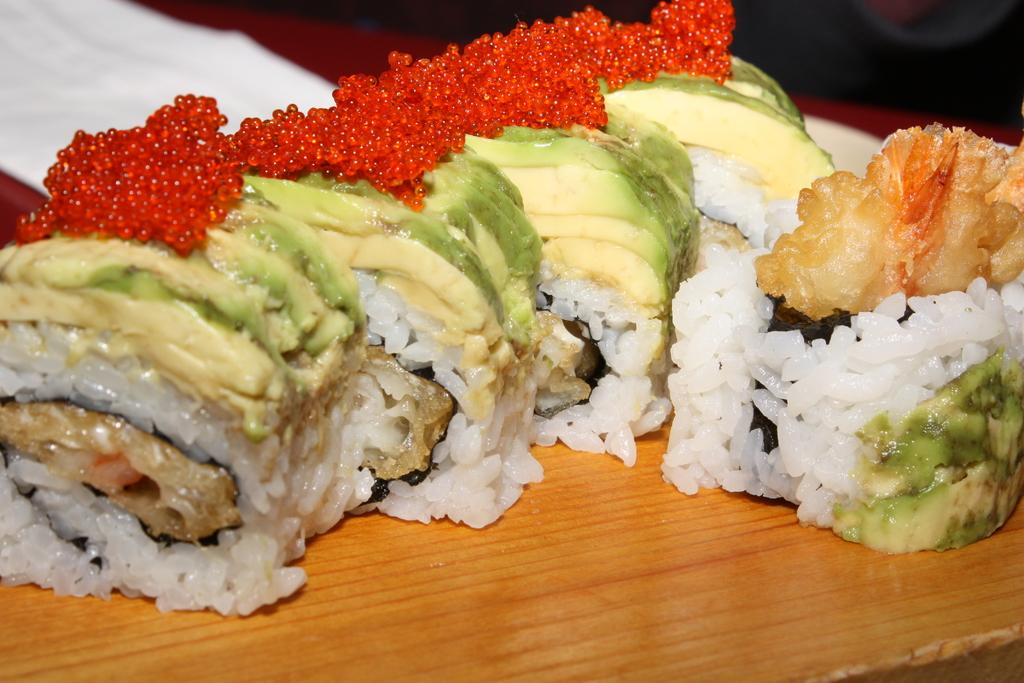What is present in the image? There is food in the image. How much money is being exchanged for the cheese in the image? There is no cheese or money present in the image; it only features food. 